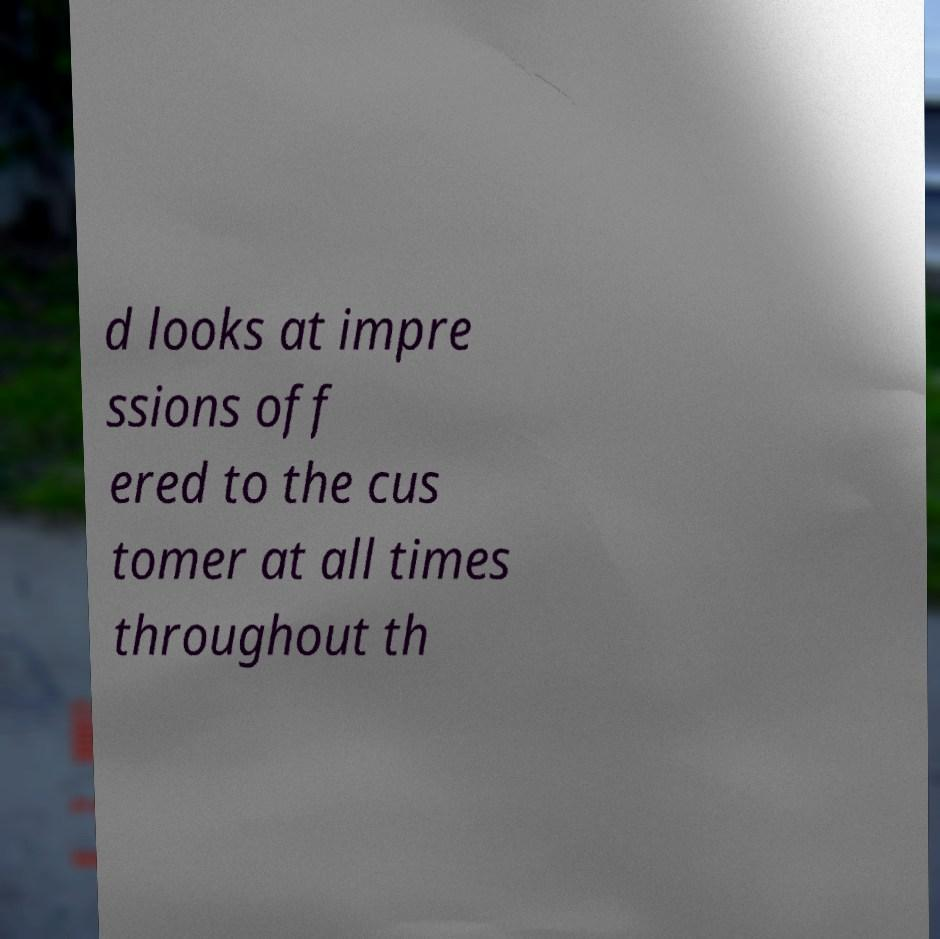Can you read and provide the text displayed in the image?This photo seems to have some interesting text. Can you extract and type it out for me? d looks at impre ssions off ered to the cus tomer at all times throughout th 